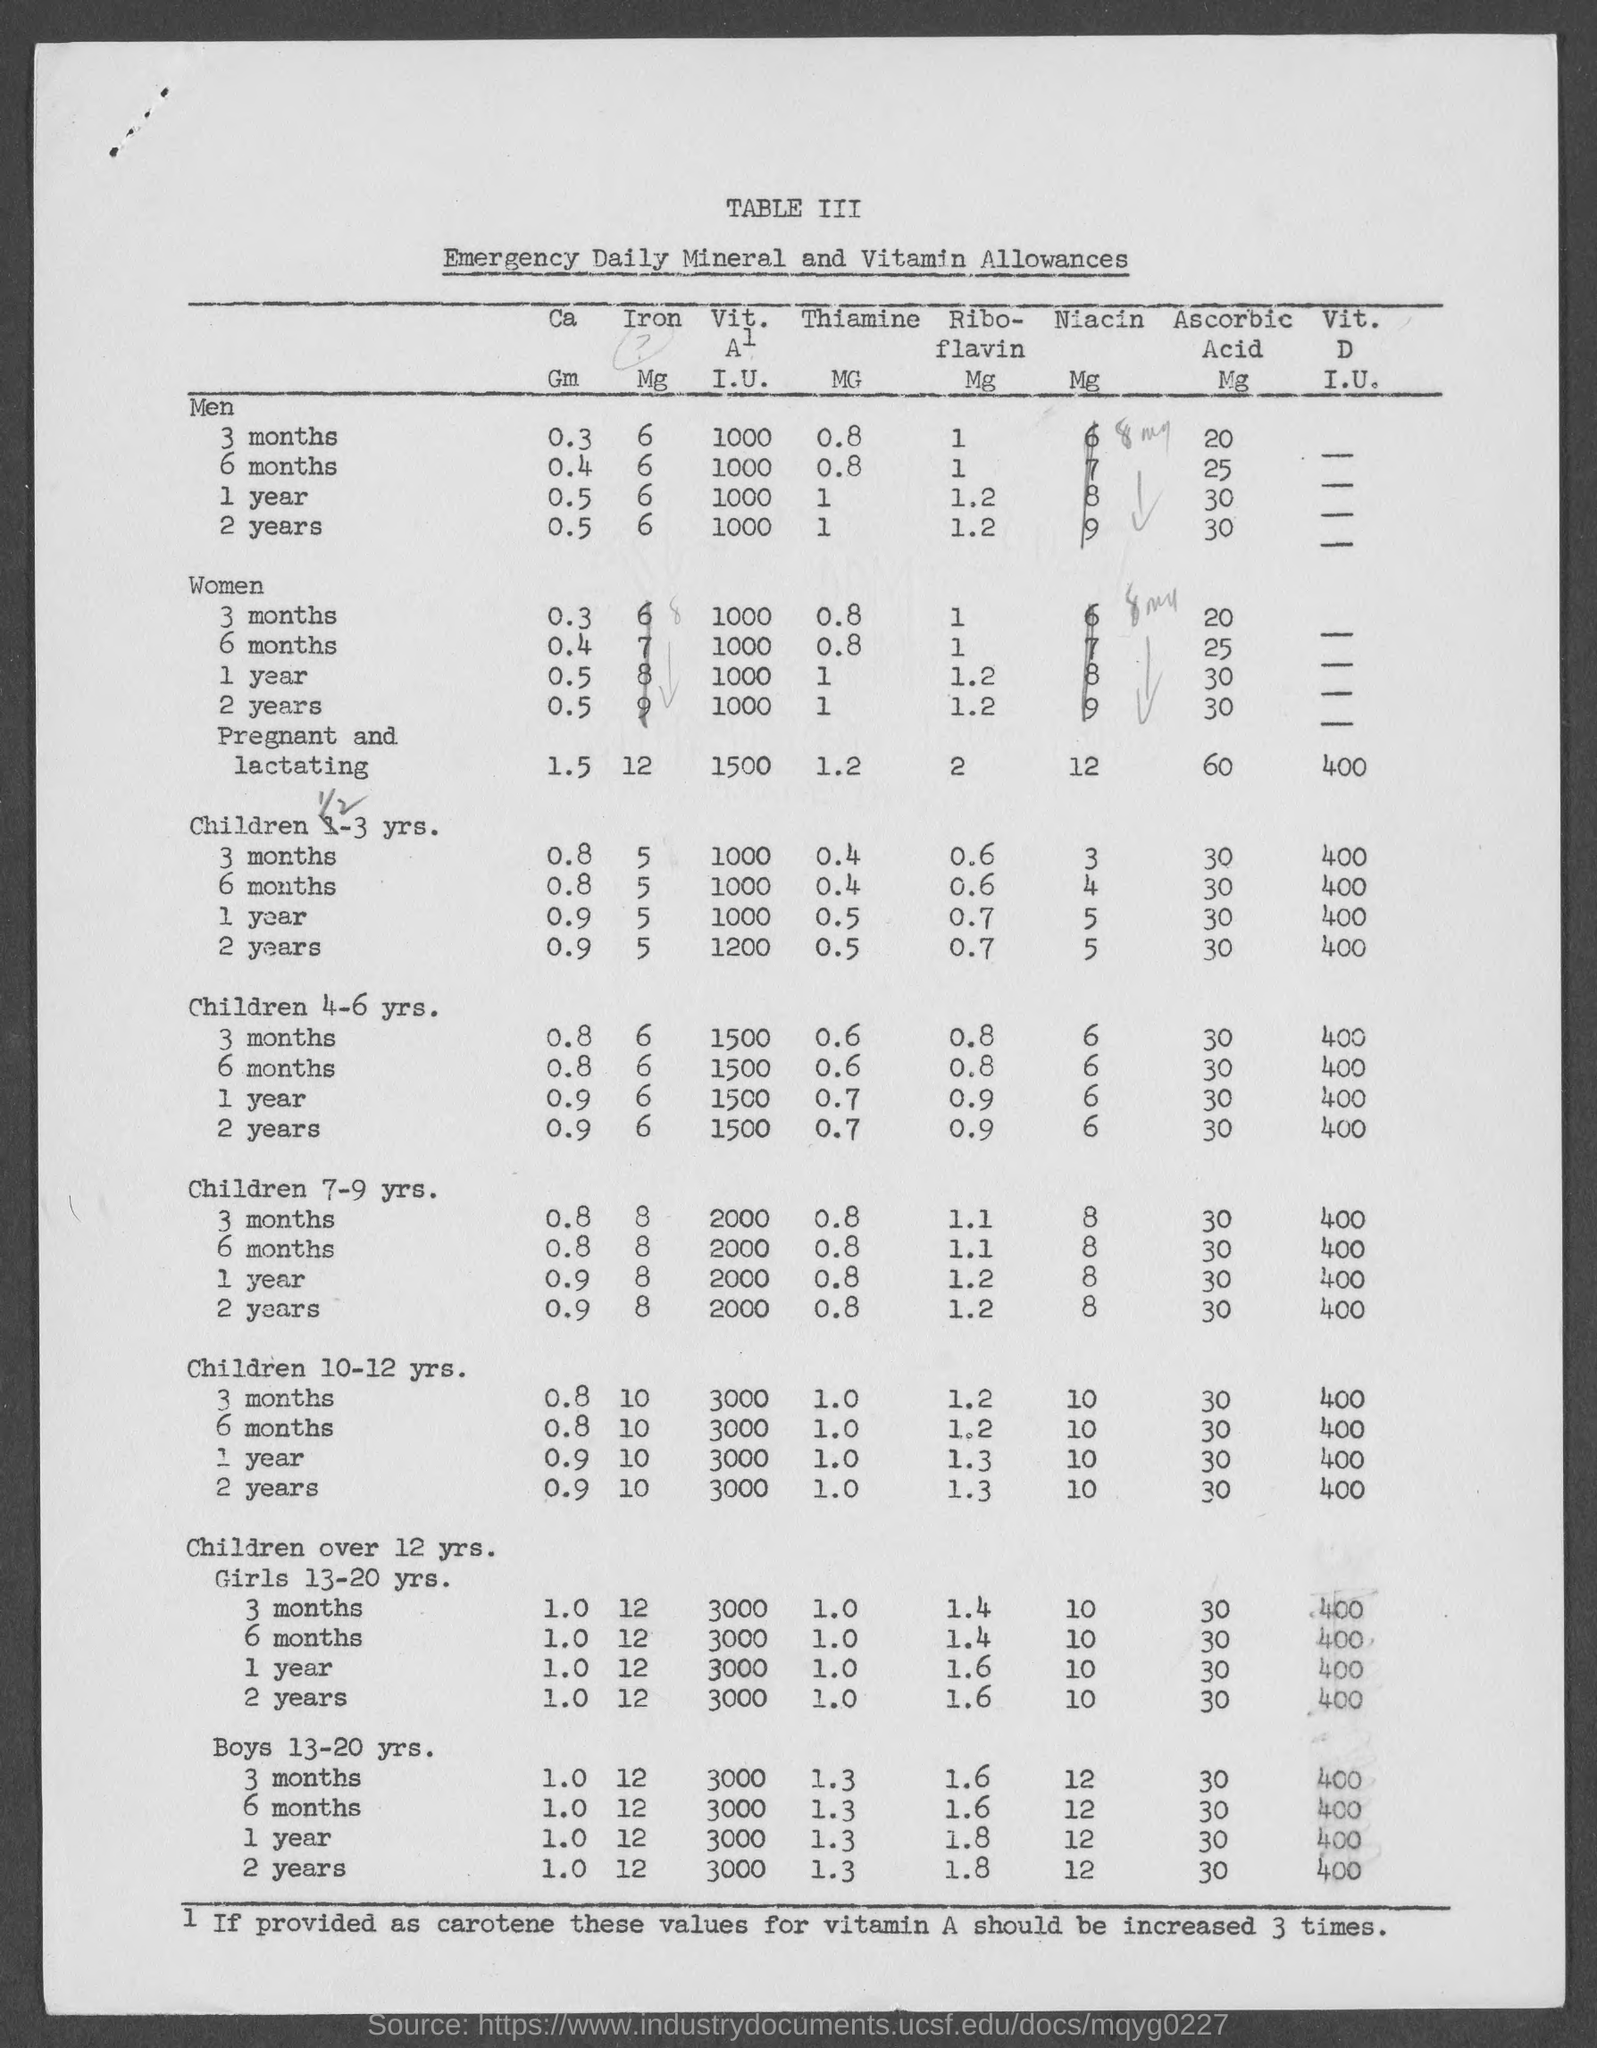What is the table no.?
Provide a short and direct response. Iii. 